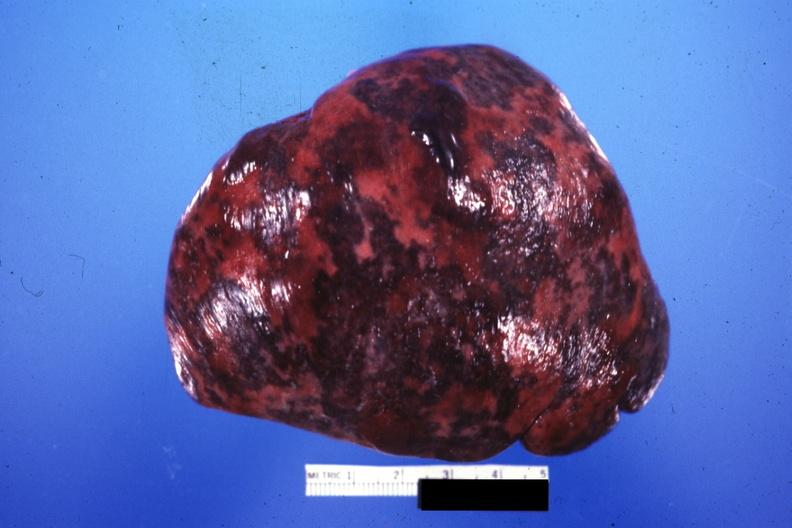s hematologic present?
Answer the question using a single word or phrase. Yes 